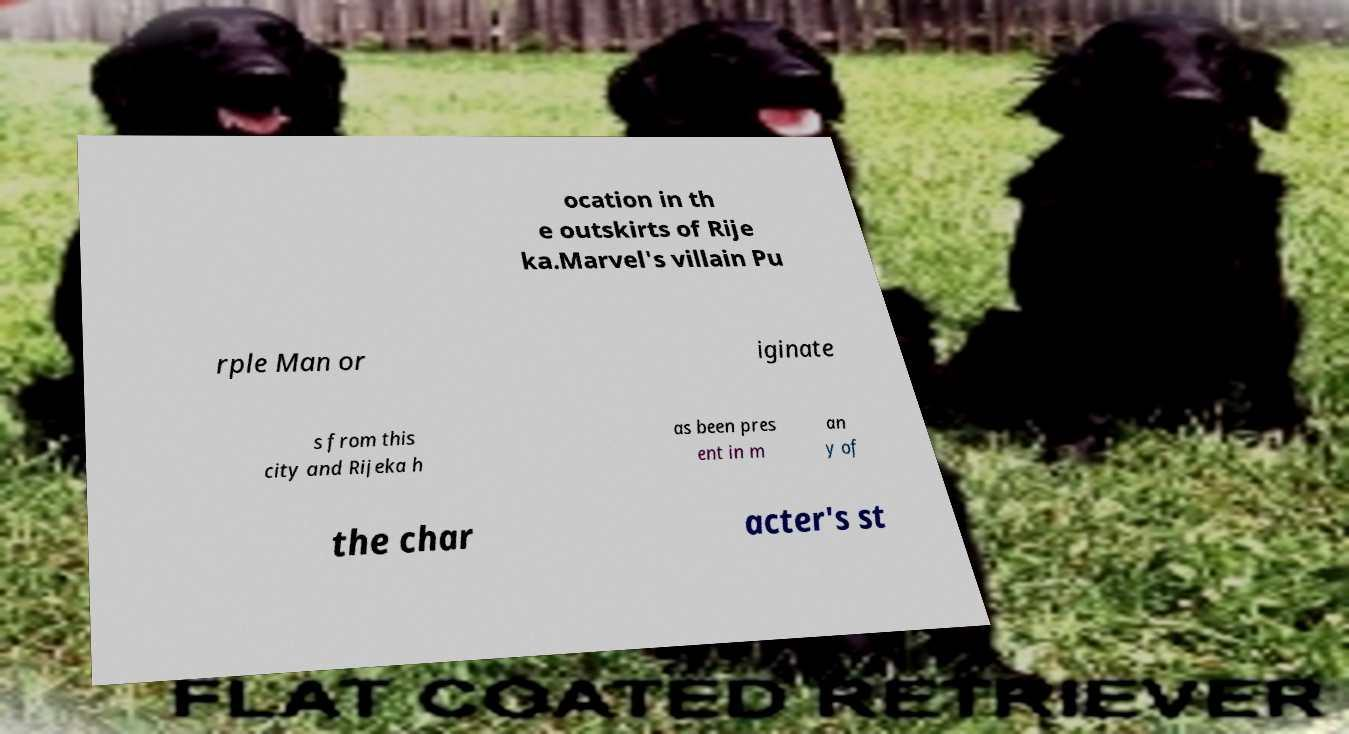Could you extract and type out the text from this image? ocation in th e outskirts of Rije ka.Marvel's villain Pu rple Man or iginate s from this city and Rijeka h as been pres ent in m an y of the char acter's st 